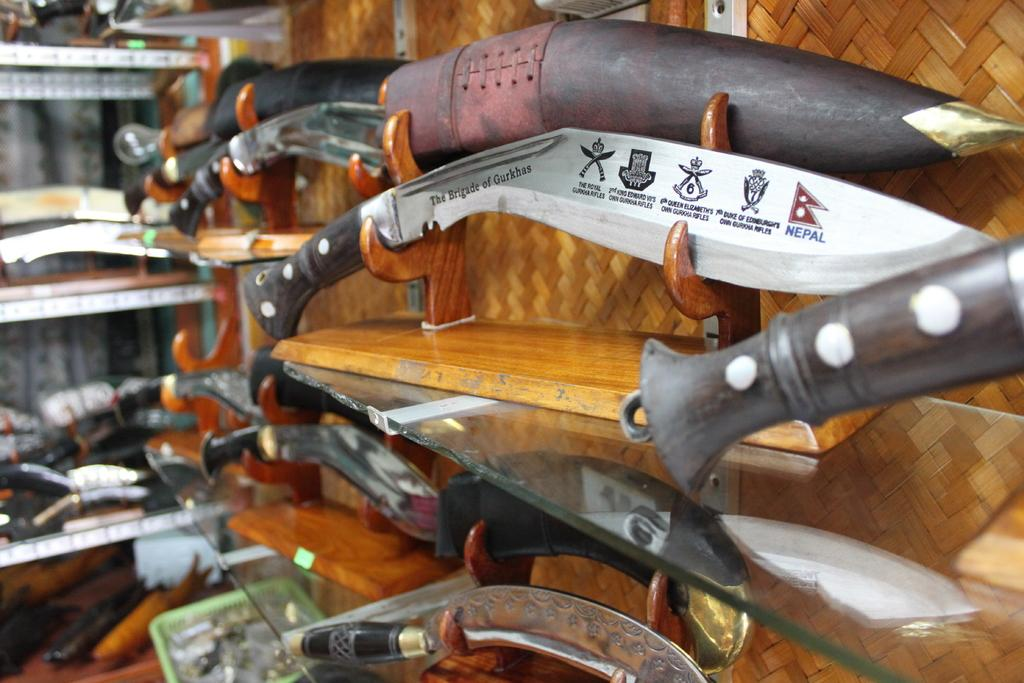What type of utensils are present in the image? There are knives in the image. What can be seen in the background of the image? There is a shelf in the background of the image. What is on the shelf in the image? The shelf has objects on it. What type of beef is being prepared by the daughter in the image? There is no daughter or beef present in the image; it only features knives and a shelf with objects. 